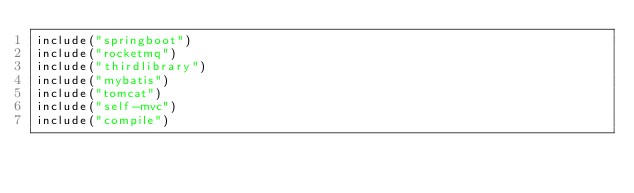Convert code to text. <code><loc_0><loc_0><loc_500><loc_500><_Kotlin_>include("springboot")
include("rocketmq")
include("thirdlibrary")
include("mybatis")
include("tomcat")
include("self-mvc")
include("compile")
</code> 